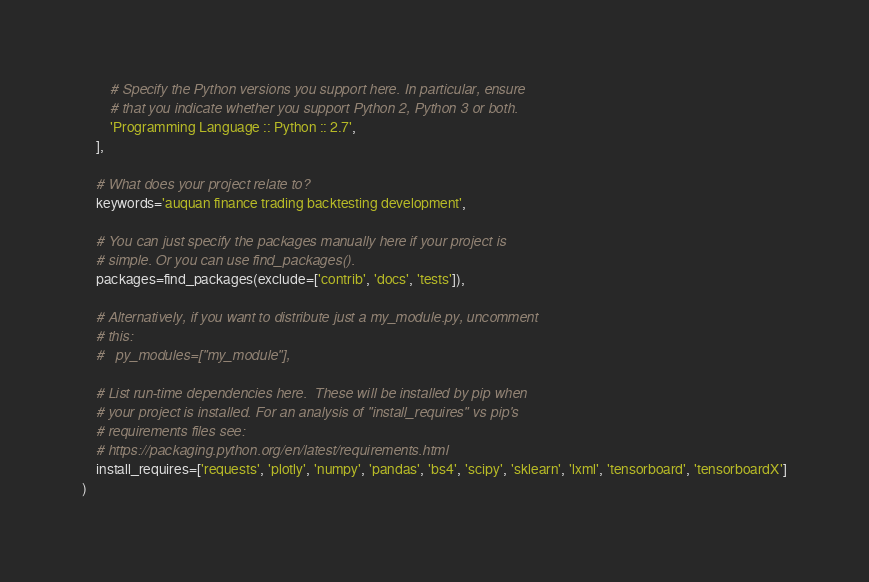<code> <loc_0><loc_0><loc_500><loc_500><_Python_>
        # Specify the Python versions you support here. In particular, ensure
        # that you indicate whether you support Python 2, Python 3 or both.
        'Programming Language :: Python :: 2.7',
    ],

    # What does your project relate to?
    keywords='auquan finance trading backtesting development',

    # You can just specify the packages manually here if your project is
    # simple. Or you can use find_packages().
    packages=find_packages(exclude=['contrib', 'docs', 'tests']),

    # Alternatively, if you want to distribute just a my_module.py, uncomment
    # this:
    #   py_modules=["my_module"],

    # List run-time dependencies here.  These will be installed by pip when
    # your project is installed. For an analysis of "install_requires" vs pip's
    # requirements files see:
    # https://packaging.python.org/en/latest/requirements.html
    install_requires=['requests', 'plotly', 'numpy', 'pandas', 'bs4', 'scipy', 'sklearn', 'lxml', 'tensorboard', 'tensorboardX']
)
</code> 